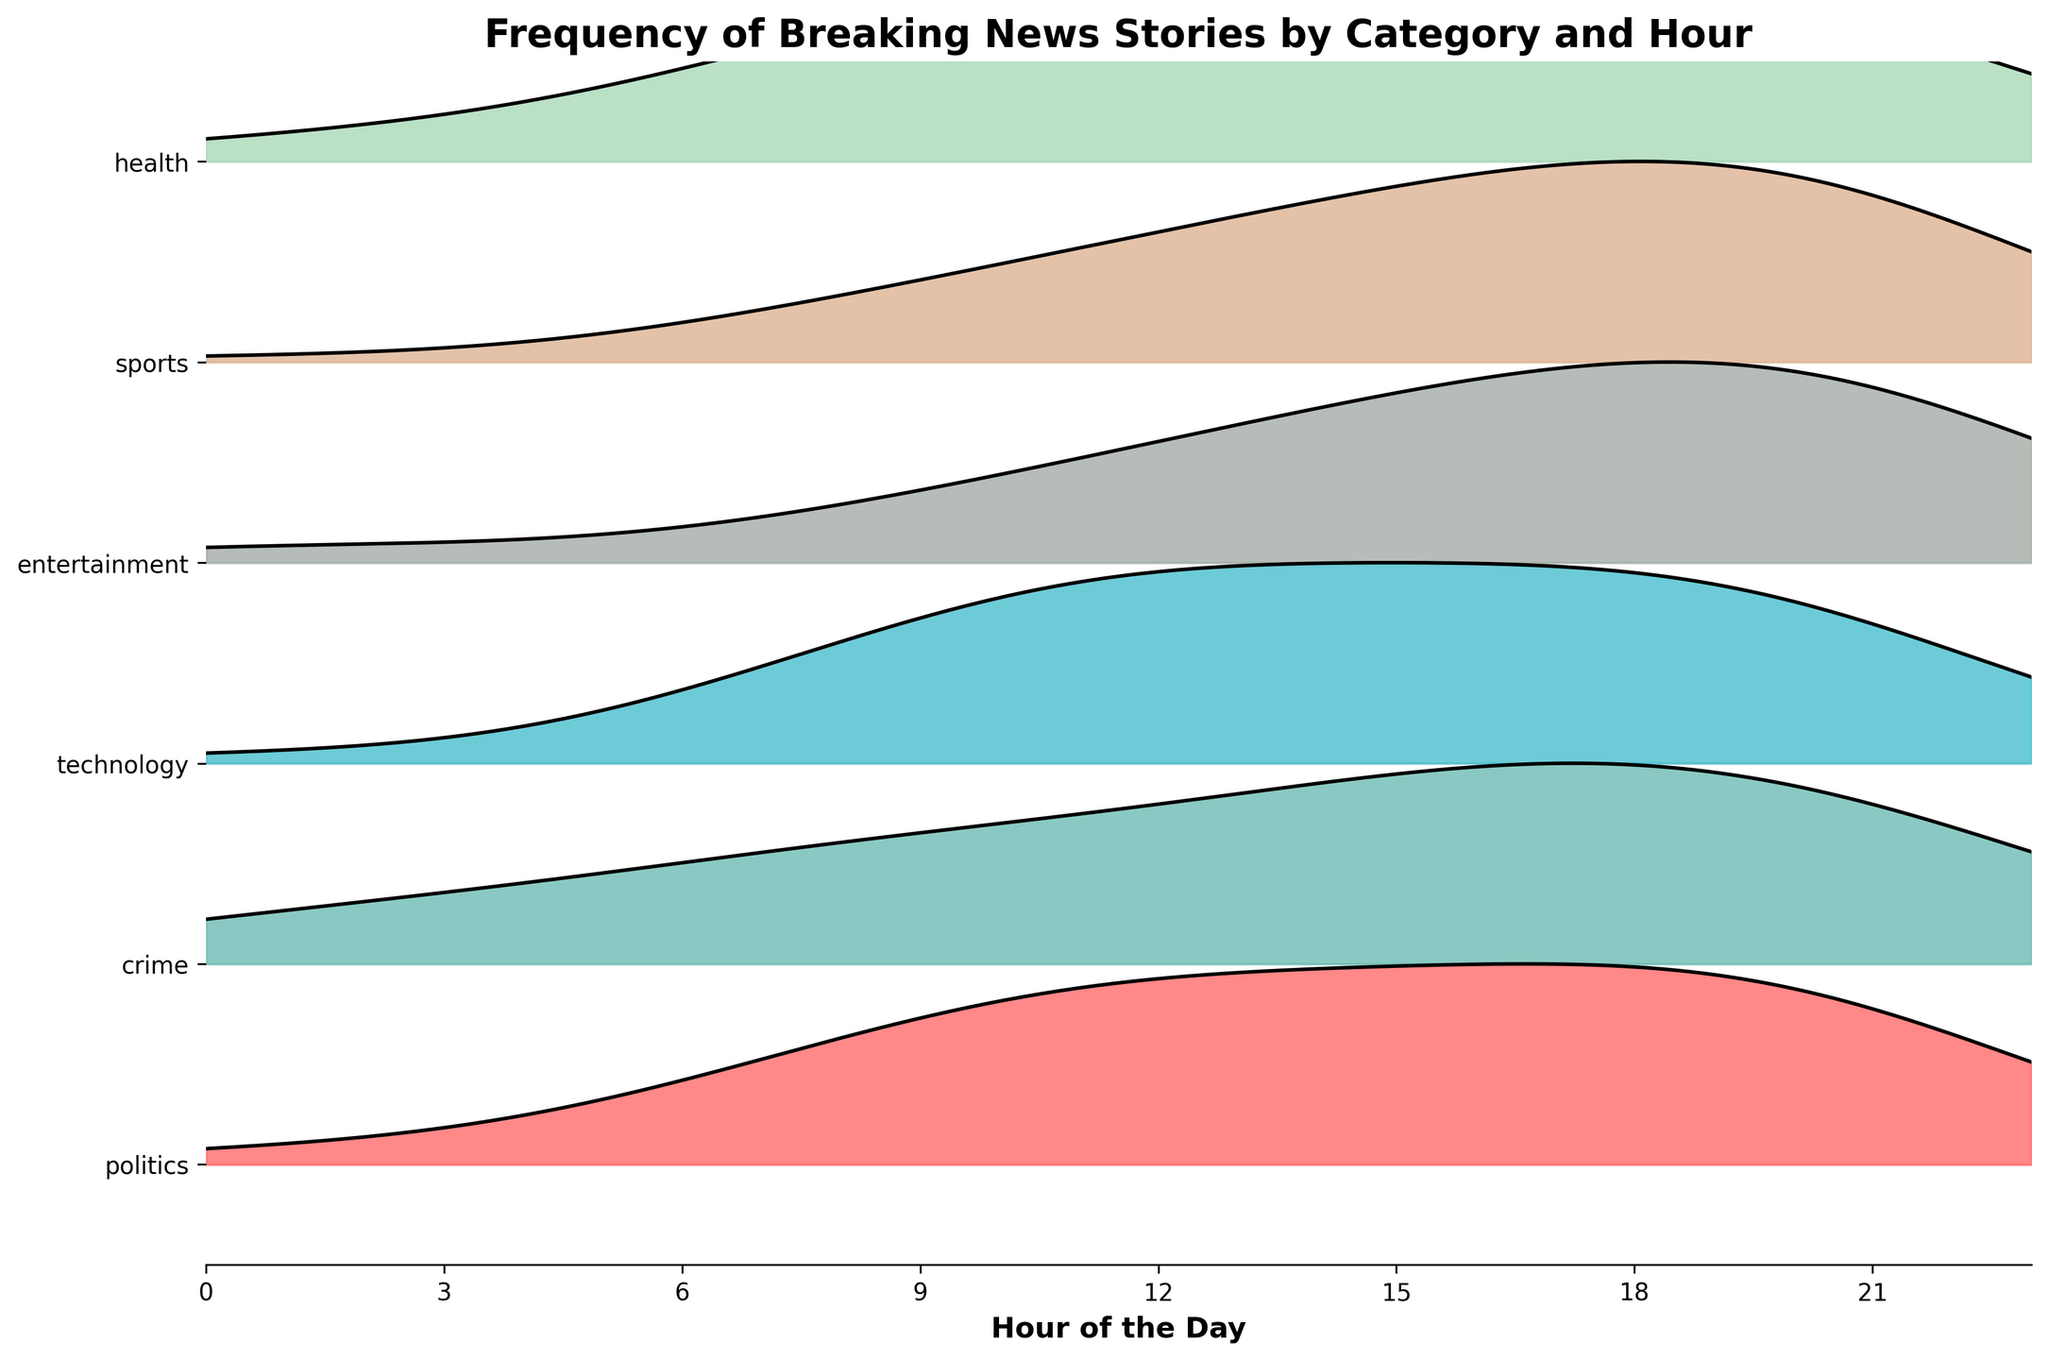what is the title of the plot? The title of a plot is often placed at the top center and is usually the largest text, providing a summary of the information presented. In this case, the title is "Frequency of Breaking News Stories by Category and Hour".
Answer: Frequency of Breaking News Stories by Category and Hour Which category has the highest density peak? The category with the highest density peak will have the tallest ridge in the plot. By visually inspecting the heights of the ridgelines, the "sports" category stands out as having the most prominent peak.
Answer: sports What is the x-axis label of the plot? The label for the x-axis provides context for the horizontal dimension of the plot. Here, it indicates the time of day, labeled as "Hour of the Day".
Answer: Hour of the Day During which hour is the frequency of "technology" news the lowest? To find when "technology" news is at its lowest frequency, observe the ridgeline representing "technology" and identify the hour where the ridge is at its lowest point. This appears to be around 2-4 AM.
Answer: 2-4 AM How does the distribution of "health" news stories compare to "entertainment" news stories over the day? Comparing distributions involves looking at the shape and height of the ridgelines. "Health" news generally has a more consistent spread throughout the day, peaking around similar times as "entertainment" but with less pronounced variations. In contrast, "entertainment" shows sharper peaks during the afternoon and evening hours.
Answer: "Health" is more consistent; "entertainment" has sharper peaks During what time range do breaking news stories in politics most frequently occur? Observe the ridgeline for "politics" and identify the time range with the highest and widest section of the ridgeline, which indicates higher frequencies. This is prominent from late morning to early evening.
Answer: Late morning to early evening Are there any categories that show a dip in frequency at midnight? To identify a dip at midnight, examine the ridgelines at the 0-hour mark. Specifically, you can see that categories like "crime", "technology", and "health" show a notable dip around midnight.
Answer: crime, technology, health What is the overall trend of "crime" news stories throughout the day? To find the trend, follow the "crime" ridgeline from left to right. "Crime" news stories increase gradually from midnight, peak in the evening hours, and then decrease slightly towards midnight.
Answer: Increases from midnight, peaks in evening, decreases towards midnight Which categories show frequent breaking news stories throughout the early morning (12 AM - 6 AM)? Ridgelines with broader widths or higher peaks from 12 AM - 6 AM represent categories with more frequent breaking news in the early morning. "Crime" and "health" particularly stand out with consistent presence during these hours.
Answer: crime, health Which news category shows a distinct peak around 5 PM? Look for the highest ridge around the 5 PM mark. The category with a pronounced peak at this time will be more visible. "Sports" clearly shows a distinct peak around this hour.
Answer: sports 